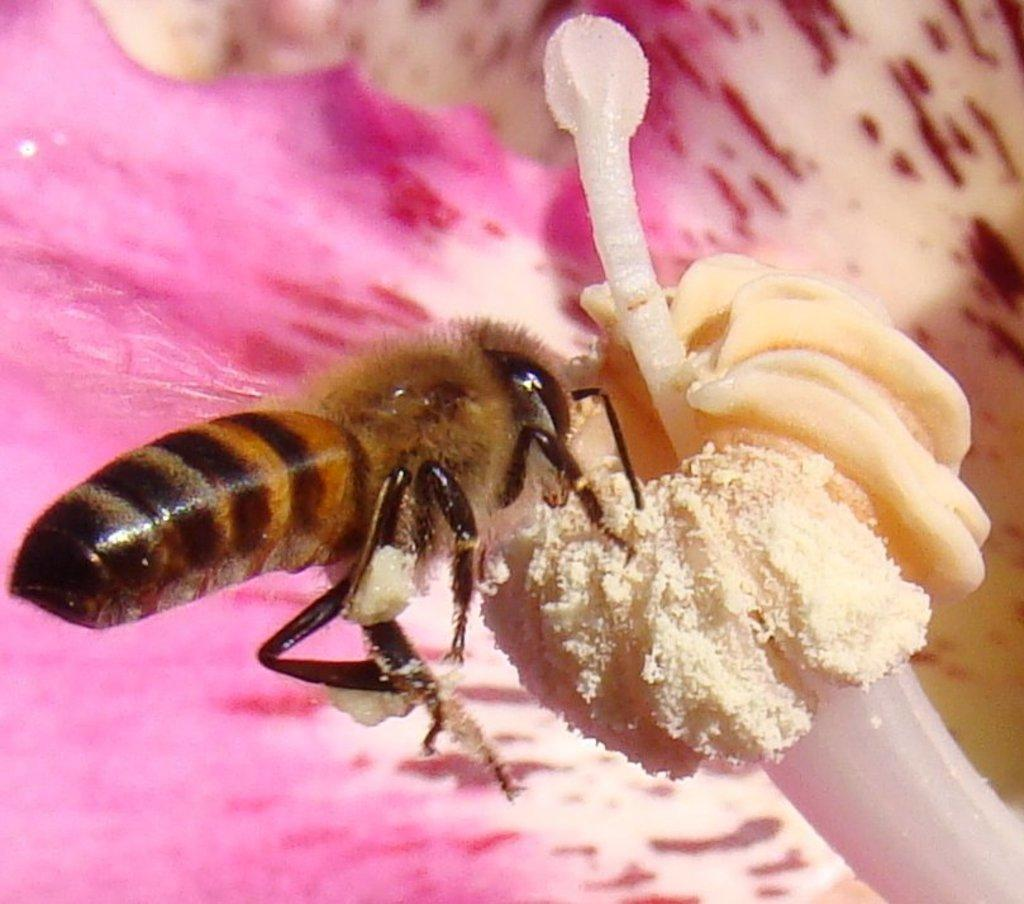What is present in the image? There is a bee in the image. Where is the bee located? The bee is on a flower. What type of education is being provided in the image? There is no indication of education in the image; it features a bee on a flower. How many chickens can be seen in the image? There are no chickens present in the image. 